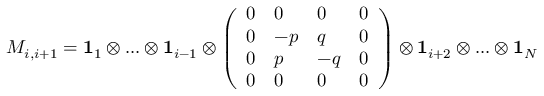<formula> <loc_0><loc_0><loc_500><loc_500>M _ { i , i + 1 } = 1 _ { 1 } \otimes \dots \otimes 1 _ { i - 1 } \otimes \left ( \begin{array} { l l l l } { 0 } & { 0 } & { 0 } & { 0 } \\ { 0 } & { - p } & { q } & { 0 } \\ { 0 } & { p } & { - q } & { 0 } \\ { 0 } & { 0 } & { 0 } & { 0 } \end{array} \right ) \otimes 1 _ { i + 2 } \otimes \dots \otimes 1 _ { N }</formula> 